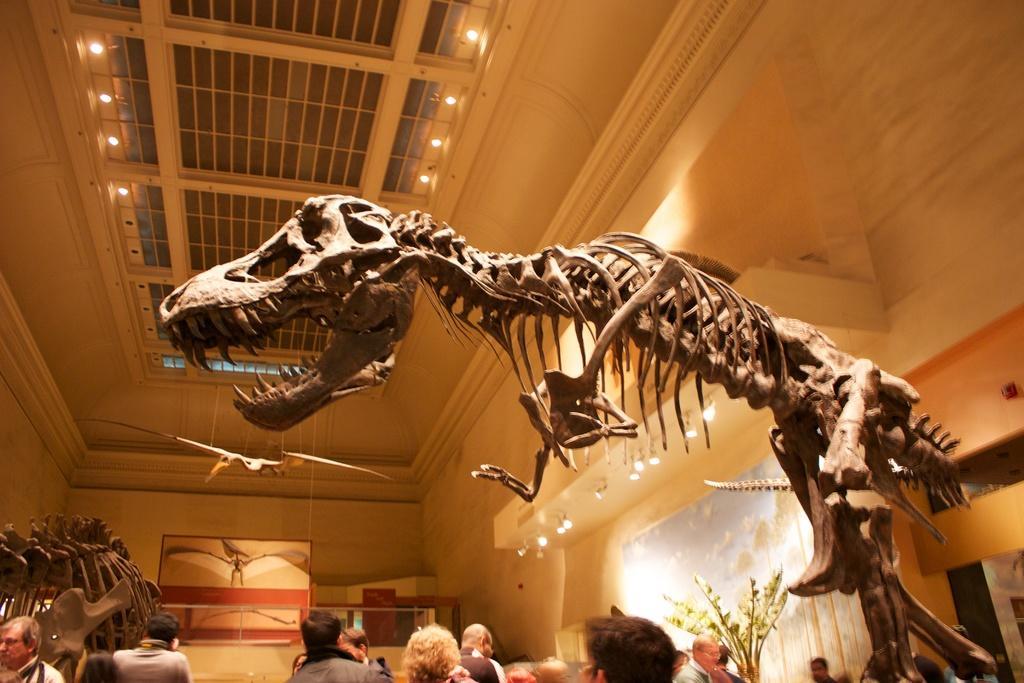Please provide a concise description of this image. Here in this picture we can see a skeleton of a dinosaur present over a place and in the front of it we can see number of people standing and watching it and we can also see other skeletons also present and we can see portraits on the wall and we can see lights present on the roof and we can also see a flower vase present. 